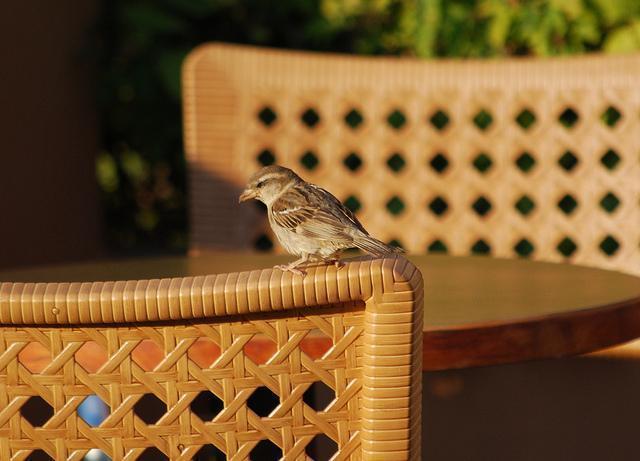What materials are the chairs made of?
Choose the correct response, then elucidate: 'Answer: answer
Rationale: rationale.'
Options: Metal, bamboo, ceramic, wood. Answer: bamboo.
Rationale: The material is woodlike.  the material is woven. 